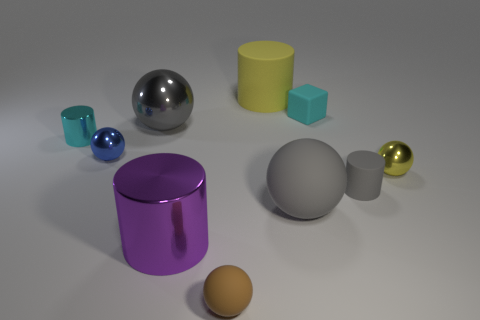Subtract all brown balls. How many balls are left? 4 Subtract 1 cubes. How many cubes are left? 0 Subtract all yellow cylinders. How many cylinders are left? 3 Add 9 gray metallic balls. How many gray metallic balls exist? 10 Subtract 0 brown blocks. How many objects are left? 10 Subtract all cylinders. How many objects are left? 6 Subtract all brown balls. Subtract all yellow cylinders. How many balls are left? 4 Subtract all gray spheres. How many gray cylinders are left? 1 Subtract all large cyan objects. Subtract all large metallic balls. How many objects are left? 9 Add 1 small blue balls. How many small blue balls are left? 2 